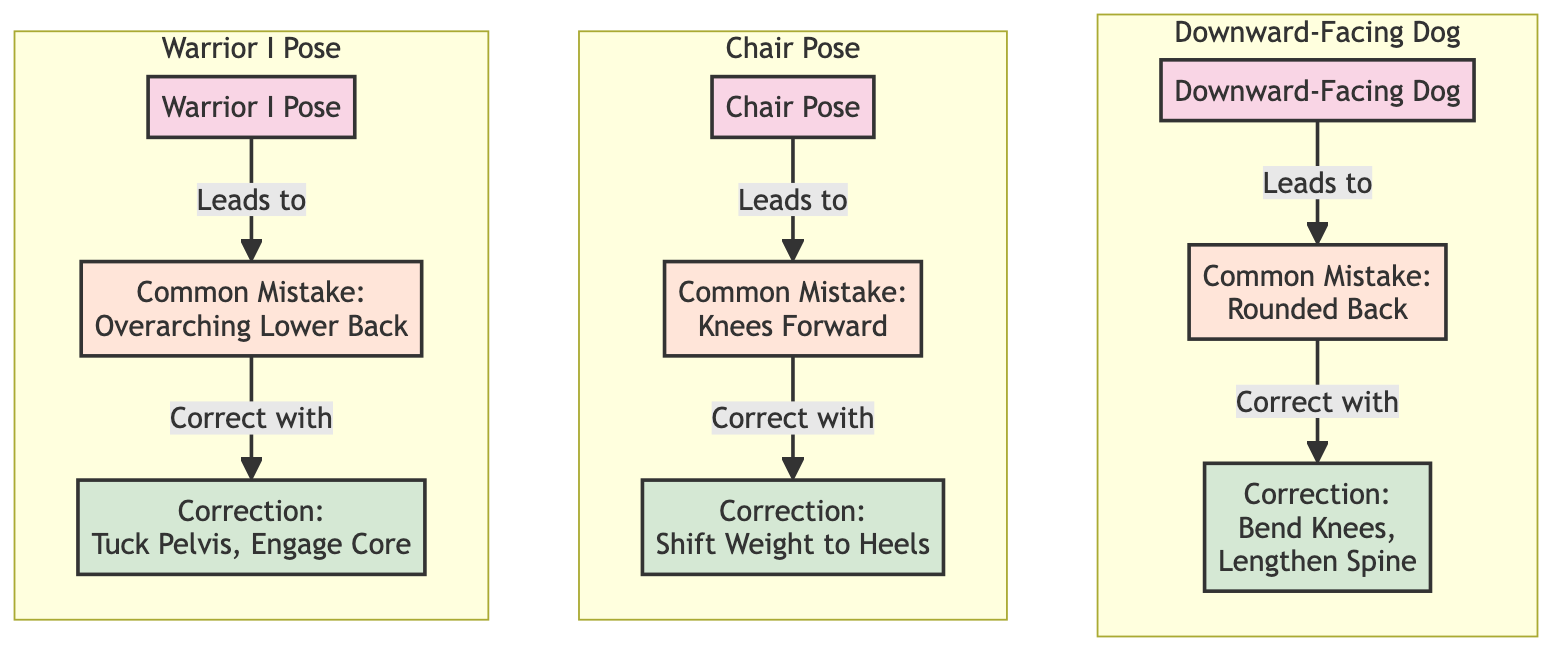What common mistake is associated with Downward-Facing Dog? The diagram indicates that the common mistake for Downward-Facing Dog is "Rounded Back."
Answer: Rounded Back What is the corrective measure for the Knee Forward mistake in Chair Pose? The diagram specifies that the corrective measure for the Knee Forward mistake in Chair Pose is to "Shift Weight to Heels."
Answer: Shift Weight to Heels How many yoga poses are depicted in the diagram? The diagram includes three yoga poses: Downward-Facing Dog, Chair Pose, and Warrior I Pose, thus totaling three.
Answer: 3 What corrective measure is recommended for Overarching Lower Back in Warrior I Pose? According to the diagram, the correction for Overarching Lower Back in Warrior I Pose is to "Tuck Pelvis, Engage Core."
Answer: Tuck Pelvis, Engage Core Which yoga pose leads to the mistake of Knees Forward? The diagram shows that Chair Pose leads to the mistake of Knees Forward.
Answer: Chair Pose How does the mistake of Rounded Back in Downward-Facing Dog relate to its corrective measure? The diagram indicates that the mistake of Rounded Back in Downward-Facing Dog can be corrected by bending the knees and lengthening the spine, thus establishing a clear relationship between them.
Answer: Bend Knees, Lengthen Spine What is the first yoga pose listed in the diagram? The first yoga pose listed in the diagram is Downward-Facing Dog.
Answer: Downward-Facing Dog What is the relationship between Warrior I Pose and Overarching Lower Back? The diagram states that Warrior I Pose leads to the mistake of Overarching Lower Back.
Answer: Leads to What does the diagram suggest to correct the mistake in Chair Pose? The diagram suggests correcting the mistake in Chair Pose, which is Knees Forward, by shifting the weight to the heels.
Answer: Shift Weight to Heels 